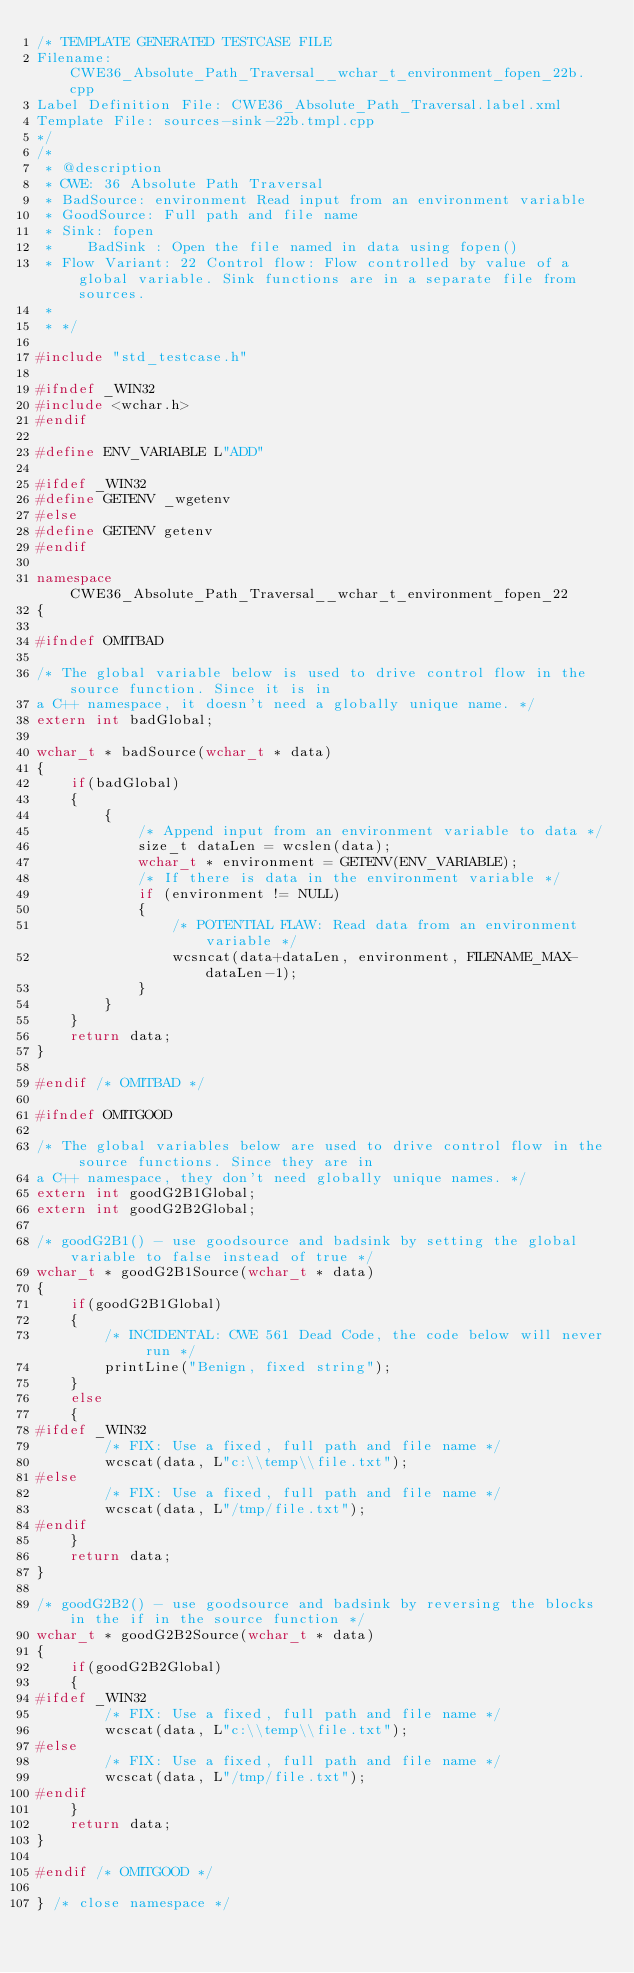<code> <loc_0><loc_0><loc_500><loc_500><_C++_>/* TEMPLATE GENERATED TESTCASE FILE
Filename: CWE36_Absolute_Path_Traversal__wchar_t_environment_fopen_22b.cpp
Label Definition File: CWE36_Absolute_Path_Traversal.label.xml
Template File: sources-sink-22b.tmpl.cpp
*/
/*
 * @description
 * CWE: 36 Absolute Path Traversal
 * BadSource: environment Read input from an environment variable
 * GoodSource: Full path and file name
 * Sink: fopen
 *    BadSink : Open the file named in data using fopen()
 * Flow Variant: 22 Control flow: Flow controlled by value of a global variable. Sink functions are in a separate file from sources.
 *
 * */

#include "std_testcase.h"

#ifndef _WIN32
#include <wchar.h>
#endif

#define ENV_VARIABLE L"ADD"

#ifdef _WIN32
#define GETENV _wgetenv
#else
#define GETENV getenv
#endif

namespace CWE36_Absolute_Path_Traversal__wchar_t_environment_fopen_22
{

#ifndef OMITBAD

/* The global variable below is used to drive control flow in the source function. Since it is in
a C++ namespace, it doesn't need a globally unique name. */
extern int badGlobal;

wchar_t * badSource(wchar_t * data)
{
    if(badGlobal)
    {
        {
            /* Append input from an environment variable to data */
            size_t dataLen = wcslen(data);
            wchar_t * environment = GETENV(ENV_VARIABLE);
            /* If there is data in the environment variable */
            if (environment != NULL)
            {
                /* POTENTIAL FLAW: Read data from an environment variable */
                wcsncat(data+dataLen, environment, FILENAME_MAX-dataLen-1);
            }
        }
    }
    return data;
}

#endif /* OMITBAD */

#ifndef OMITGOOD

/* The global variables below are used to drive control flow in the source functions. Since they are in
a C++ namespace, they don't need globally unique names. */
extern int goodG2B1Global;
extern int goodG2B2Global;

/* goodG2B1() - use goodsource and badsink by setting the global variable to false instead of true */
wchar_t * goodG2B1Source(wchar_t * data)
{
    if(goodG2B1Global)
    {
        /* INCIDENTAL: CWE 561 Dead Code, the code below will never run */
        printLine("Benign, fixed string");
    }
    else
    {
#ifdef _WIN32
        /* FIX: Use a fixed, full path and file name */
        wcscat(data, L"c:\\temp\\file.txt");
#else
        /* FIX: Use a fixed, full path and file name */
        wcscat(data, L"/tmp/file.txt");
#endif
    }
    return data;
}

/* goodG2B2() - use goodsource and badsink by reversing the blocks in the if in the source function */
wchar_t * goodG2B2Source(wchar_t * data)
{
    if(goodG2B2Global)
    {
#ifdef _WIN32
        /* FIX: Use a fixed, full path and file name */
        wcscat(data, L"c:\\temp\\file.txt");
#else
        /* FIX: Use a fixed, full path and file name */
        wcscat(data, L"/tmp/file.txt");
#endif
    }
    return data;
}

#endif /* OMITGOOD */

} /* close namespace */
</code> 